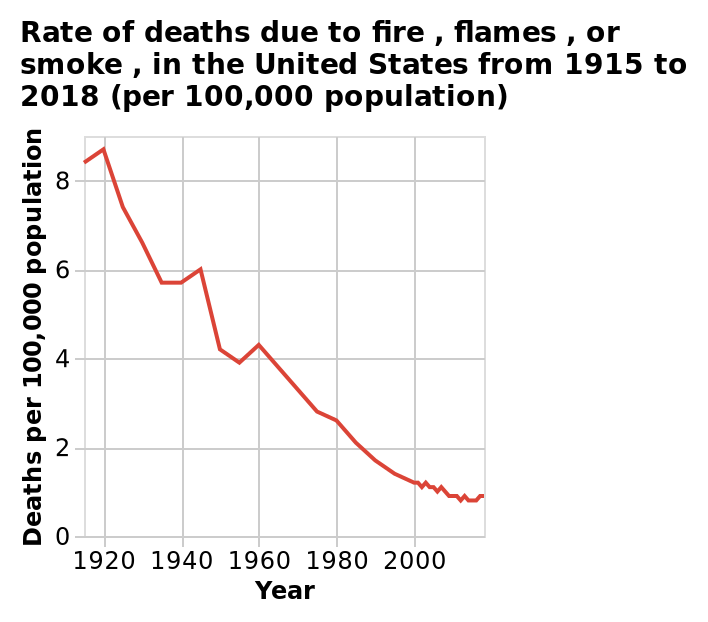<image>
What is the title of the line diagram?  The title of the line diagram is "Rate of deaths due to fire, flames, or smoke, in the United States from 1915 to 2018 (per 100,000 population)." Offer a thorough analysis of the image. In 1915 8.25 deaths of every 100,000 were due to fire, flames or smoke in the US. This trend declined to one in 2018. However, exception occurred in 1945 and 1960 where deaths were 6 and 4.25 respectfully. 